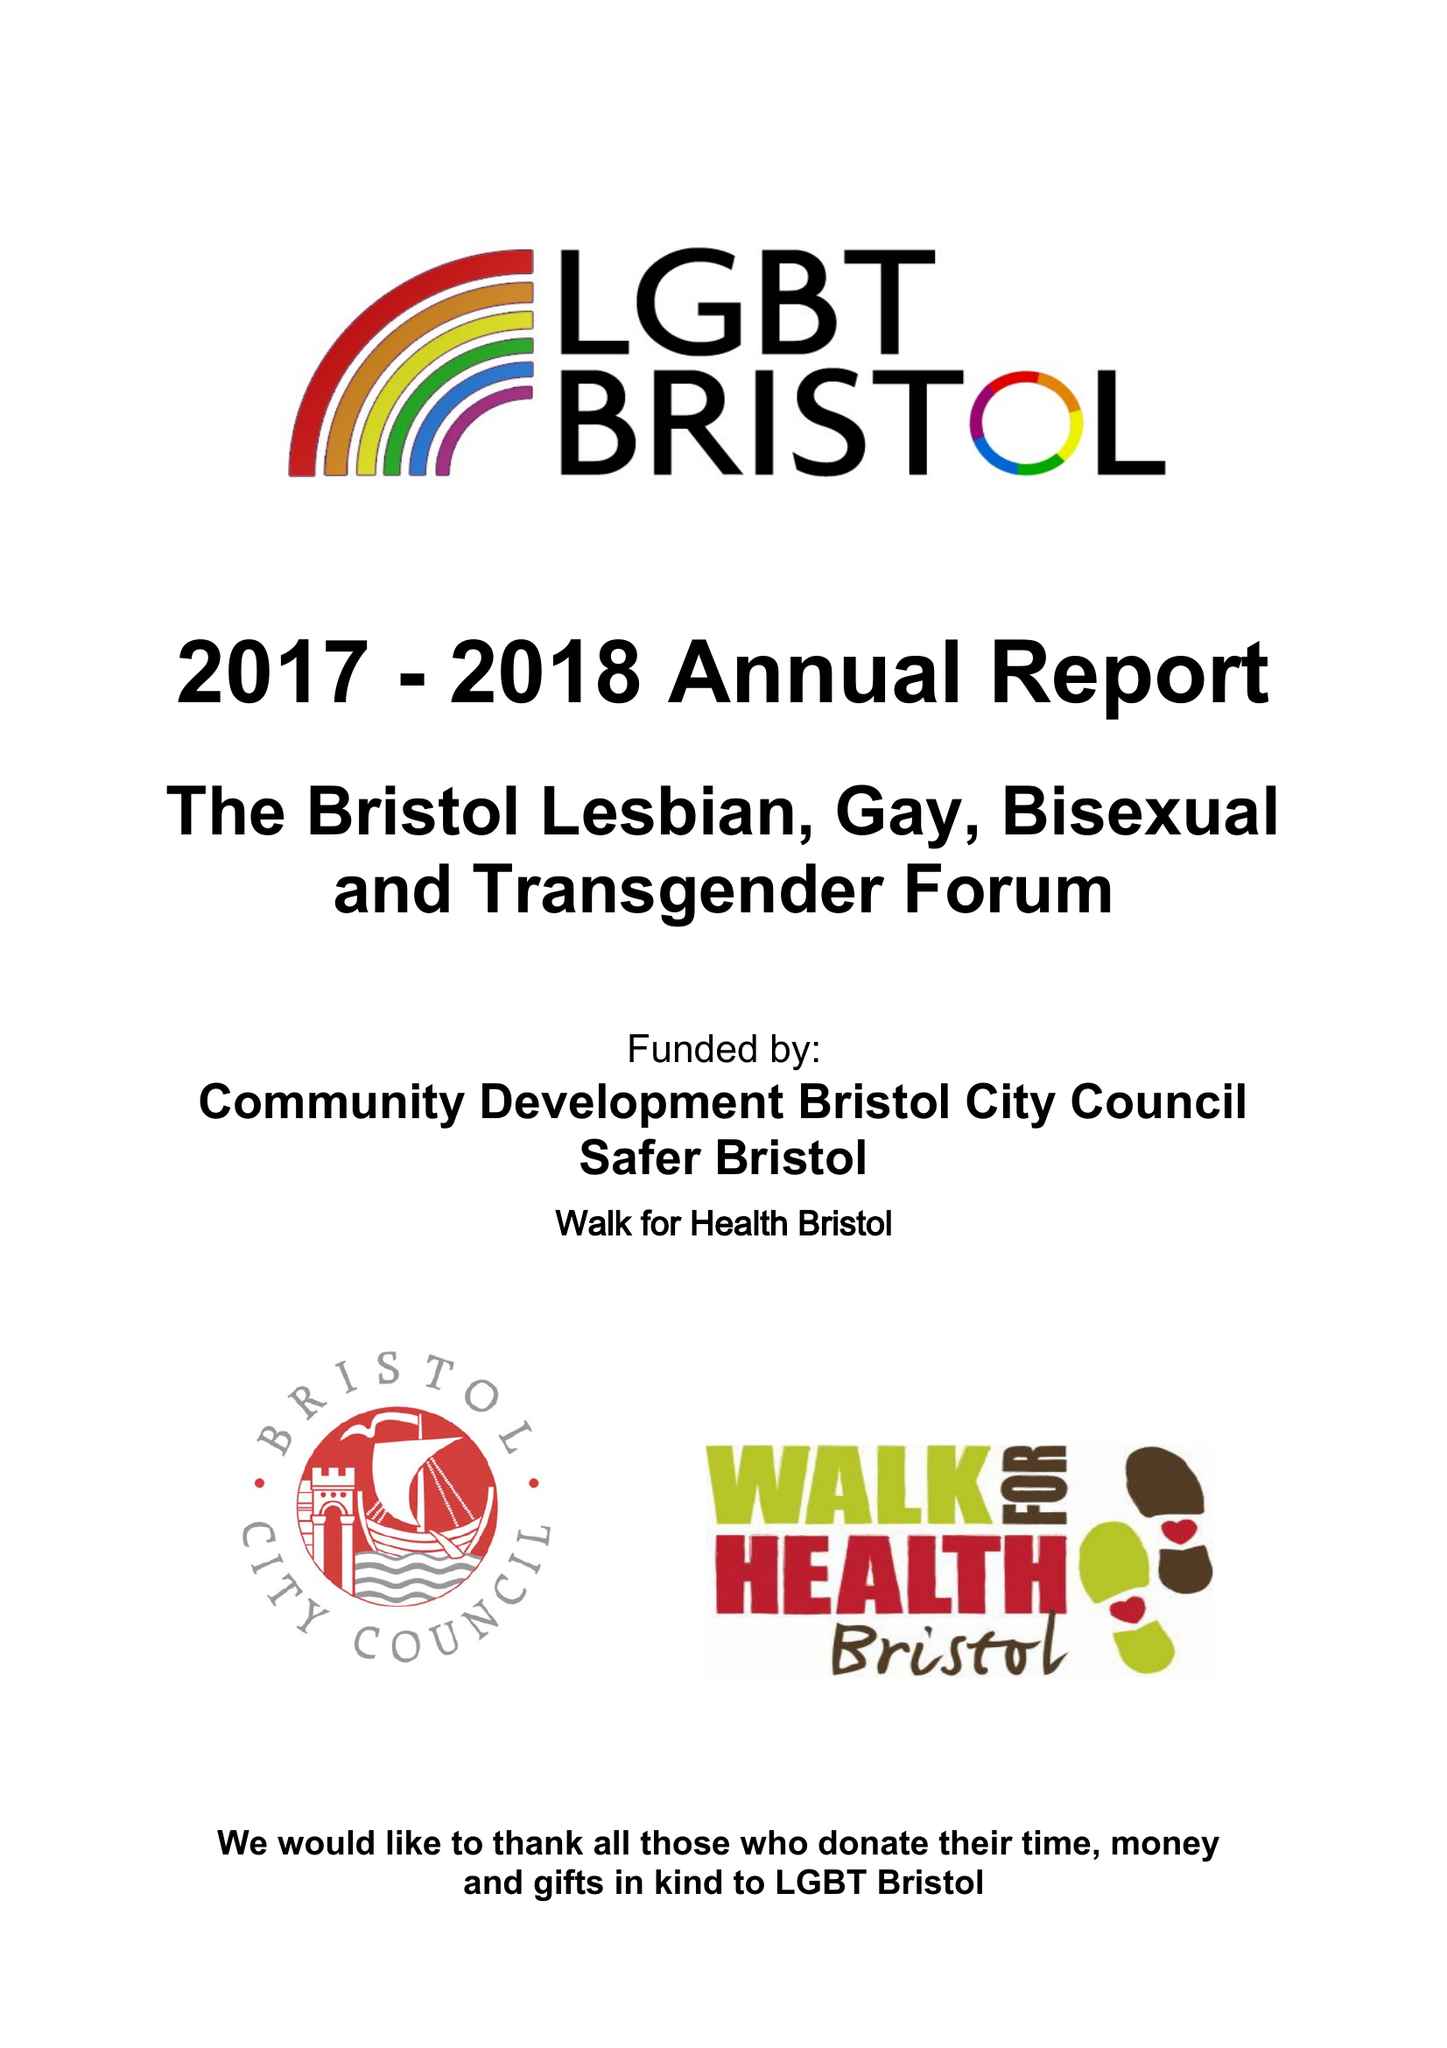What is the value for the address__postcode?
Answer the question using a single word or phrase. BS4 1DQ 